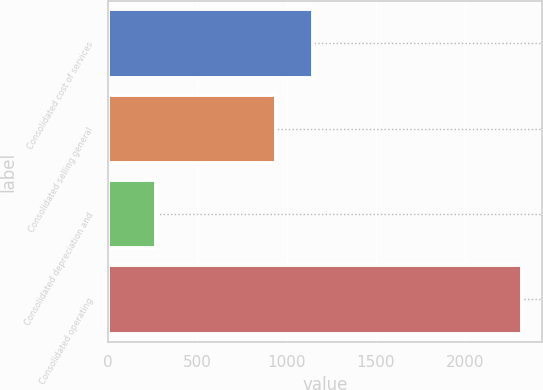<chart> <loc_0><loc_0><loc_500><loc_500><bar_chart><fcel>Consolidated cost of services<fcel>Consolidated selling general<fcel>Consolidated depreciation and<fcel>Consolidated operating<nl><fcel>1146.44<fcel>941<fcel>265.4<fcel>2319.8<nl></chart> 